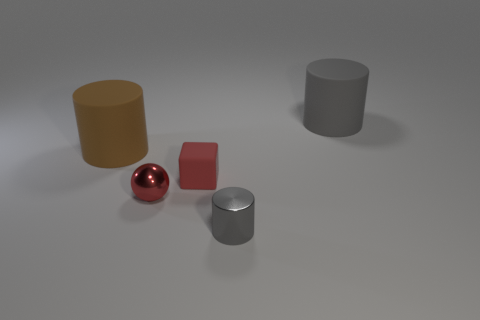Subtract all big gray rubber cylinders. How many cylinders are left? 2 Add 1 gray rubber things. How many objects exist? 6 Subtract all brown cylinders. How many cylinders are left? 2 Subtract all cylinders. How many objects are left? 2 Subtract all green cylinders. How many gray blocks are left? 0 Subtract all brown metal balls. Subtract all gray metal things. How many objects are left? 4 Add 5 small gray metal objects. How many small gray metal objects are left? 6 Add 3 gray balls. How many gray balls exist? 3 Subtract 1 red balls. How many objects are left? 4 Subtract 1 balls. How many balls are left? 0 